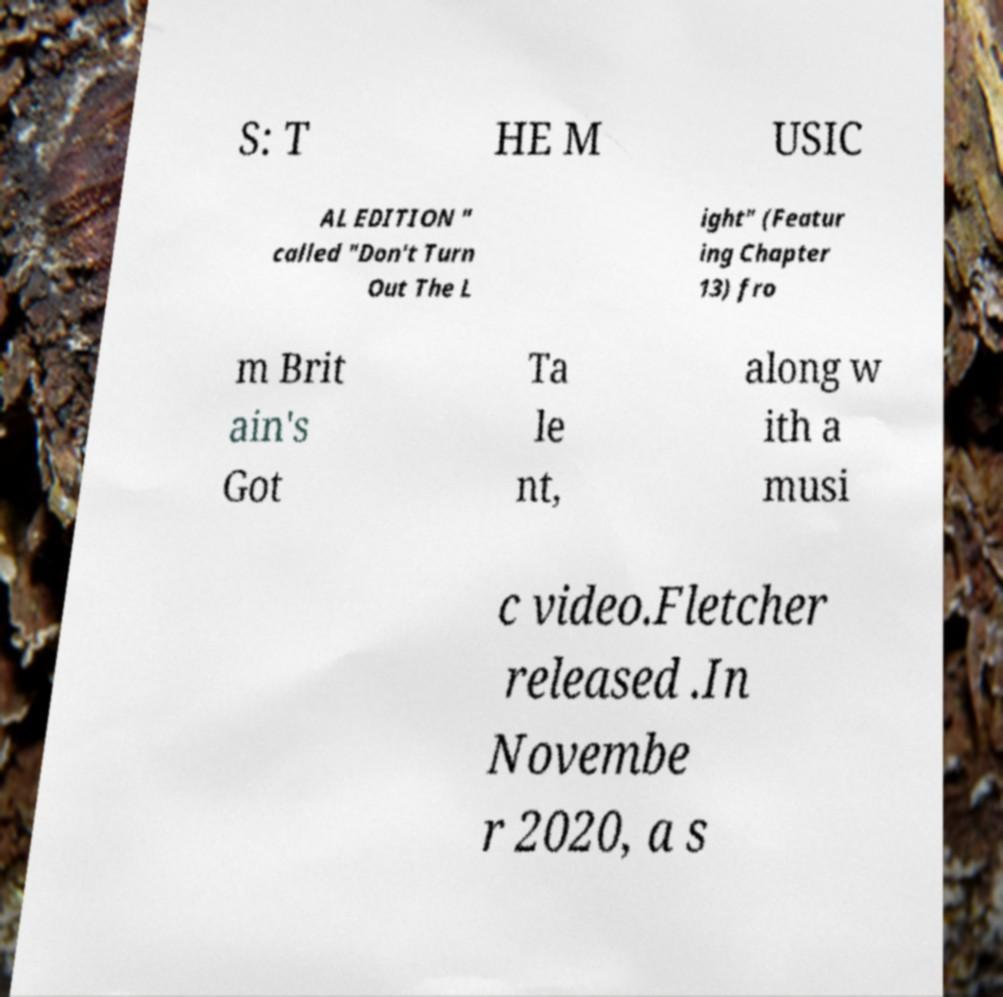Please identify and transcribe the text found in this image. S: T HE M USIC AL EDITION " called "Don't Turn Out The L ight" (Featur ing Chapter 13) fro m Brit ain's Got Ta le nt, along w ith a musi c video.Fletcher released .In Novembe r 2020, a s 